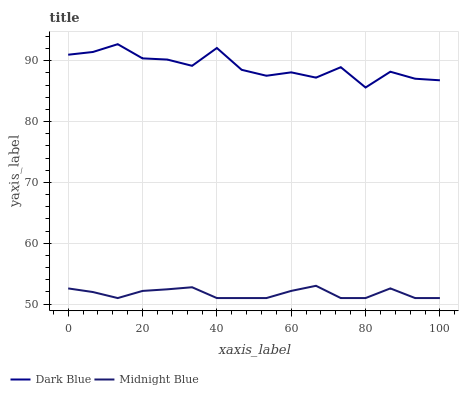Does Midnight Blue have the maximum area under the curve?
Answer yes or no. No. Is Midnight Blue the roughest?
Answer yes or no. No. Does Midnight Blue have the highest value?
Answer yes or no. No. Is Midnight Blue less than Dark Blue?
Answer yes or no. Yes. Is Dark Blue greater than Midnight Blue?
Answer yes or no. Yes. Does Midnight Blue intersect Dark Blue?
Answer yes or no. No. 